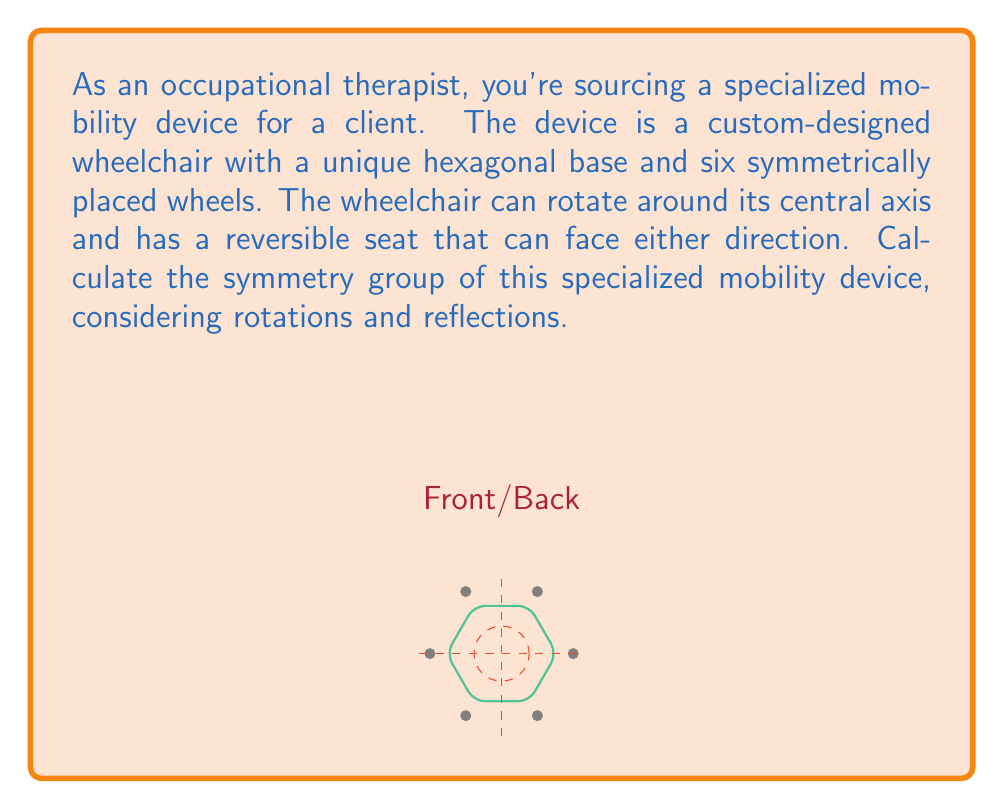Provide a solution to this math problem. To determine the symmetry group of this specialized mobility device, we need to consider all possible symmetry operations:

1. Rotations:
   - The wheelchair can rotate around its central axis.
   - Due to its hexagonal base, it has 6-fold rotational symmetry.
   - Possible rotations: 0°, 60°, 120°, 180°, 240°, 300°

2. Reflections:
   - The device has 6 lines of reflection symmetry:
     - 3 passing through opposite vertices
     - 3 passing through the midpoints of opposite sides

3. Identity:
   - The identity operation (no change) is always included.

4. Reversible seat:
   - The seat can face either direction, which is equivalent to a 180° rotation or a reflection across the axis perpendicular to the seat's direction.

These symmetry operations form a group. To identify this group, we need to count the total number of symmetry operations:

- 6 rotations (including identity)
- 6 reflections
- Total: 12 symmetry operations

The group with 12 elements that includes these types of symmetries is the dihedral group $D_6$ (also written as $D_{12}$ in some notations).

Properties of $D_6$:
- Order of the group: 12
- Generators: r (60° rotation) and s (reflection)
- Presentation: $\langle r,s | r^6 = s^2 = (rs)^2 = e \rangle$

The elements of $D_6$ can be written as:
$$D_6 = \{e, r, r^2, r^3, r^4, r^5, s, sr, sr^2, sr^3, sr^4, sr^5\}$$

Where $e$ is the identity, $r$ is a 60° rotation, and $s$ is a reflection.
Answer: $D_6$ 